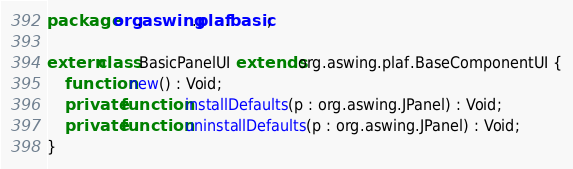<code> <loc_0><loc_0><loc_500><loc_500><_Haxe_>package org.aswing.plaf.basic;

extern class BasicPanelUI extends org.aswing.plaf.BaseComponentUI {
	function new() : Void;
	private function installDefaults(p : org.aswing.JPanel) : Void;
	private function uninstallDefaults(p : org.aswing.JPanel) : Void;
}
</code> 